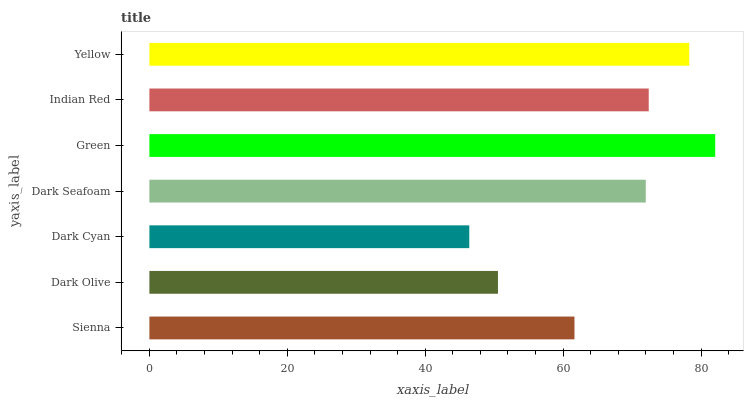Is Dark Cyan the minimum?
Answer yes or no. Yes. Is Green the maximum?
Answer yes or no. Yes. Is Dark Olive the minimum?
Answer yes or no. No. Is Dark Olive the maximum?
Answer yes or no. No. Is Sienna greater than Dark Olive?
Answer yes or no. Yes. Is Dark Olive less than Sienna?
Answer yes or no. Yes. Is Dark Olive greater than Sienna?
Answer yes or no. No. Is Sienna less than Dark Olive?
Answer yes or no. No. Is Dark Seafoam the high median?
Answer yes or no. Yes. Is Dark Seafoam the low median?
Answer yes or no. Yes. Is Yellow the high median?
Answer yes or no. No. Is Dark Olive the low median?
Answer yes or no. No. 